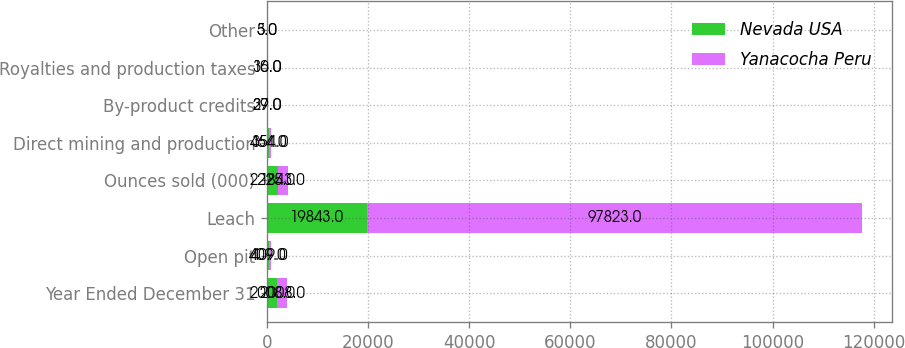<chart> <loc_0><loc_0><loc_500><loc_500><stacked_bar_chart><ecel><fcel>Year Ended December 31<fcel>Open pit<fcel>Leach<fcel>Ounces sold (000)<fcel>Direct mining and production<fcel>By-product credits<fcel>Royalties and production taxes<fcel>Other<nl><fcel>Nevada USA<fcel>2008<fcel>409<fcel>19843<fcel>2225<fcel>464<fcel>39<fcel>30<fcel>5<nl><fcel>Yanacocha Peru<fcel>2008<fcel>409<fcel>97823<fcel>1843<fcel>354<fcel>27<fcel>16<fcel>3<nl></chart> 